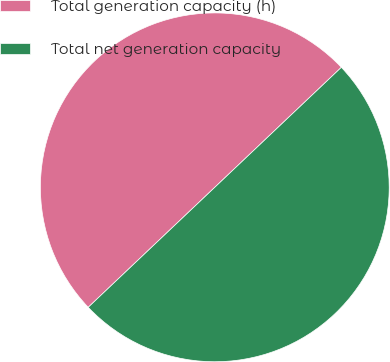Convert chart to OTSL. <chart><loc_0><loc_0><loc_500><loc_500><pie_chart><fcel>Total generation capacity (h)<fcel>Total net generation capacity<nl><fcel>50.0%<fcel>50.0%<nl></chart> 